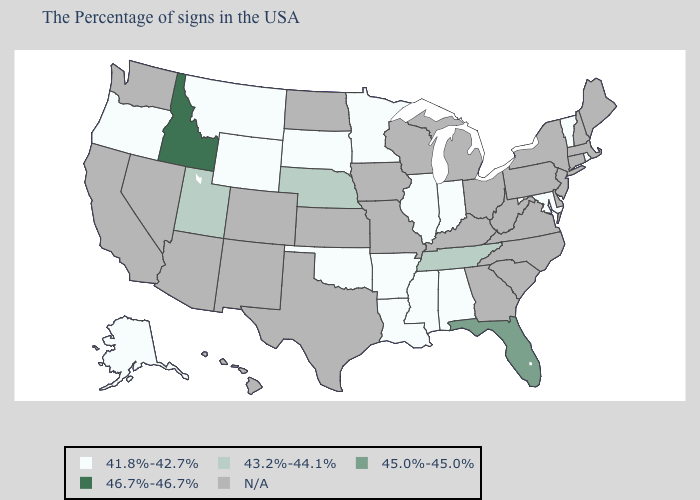Does the map have missing data?
Short answer required. Yes. What is the lowest value in states that border Minnesota?
Quick response, please. 41.8%-42.7%. Among the states that border Georgia , which have the highest value?
Write a very short answer. Florida. What is the value of North Dakota?
Answer briefly. N/A. Name the states that have a value in the range N/A?
Short answer required. Maine, Massachusetts, New Hampshire, Connecticut, New York, New Jersey, Delaware, Pennsylvania, Virginia, North Carolina, South Carolina, West Virginia, Ohio, Georgia, Michigan, Kentucky, Wisconsin, Missouri, Iowa, Kansas, Texas, North Dakota, Colorado, New Mexico, Arizona, Nevada, California, Washington, Hawaii. How many symbols are there in the legend?
Concise answer only. 5. What is the highest value in the USA?
Concise answer only. 46.7%-46.7%. What is the value of Massachusetts?
Keep it brief. N/A. What is the value of Kentucky?
Give a very brief answer. N/A. Does Alaska have the highest value in the USA?
Be succinct. No. What is the value of Ohio?
Quick response, please. N/A. What is the value of Nebraska?
Give a very brief answer. 43.2%-44.1%. What is the value of Tennessee?
Give a very brief answer. 43.2%-44.1%. Among the states that border Wisconsin , which have the lowest value?
Give a very brief answer. Illinois, Minnesota. What is the value of South Carolina?
Short answer required. N/A. 